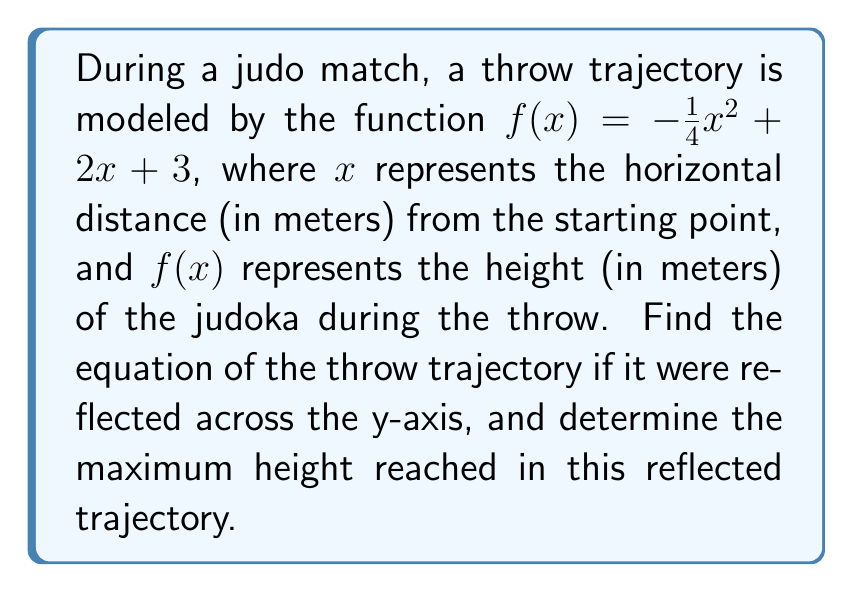Teach me how to tackle this problem. To solve this problem, we'll follow these steps:

1) To reflect a function across the y-axis, we replace every $x$ with $-x$ in the original function. This gives us:

   $g(x) = -\frac{1}{4}(-x)^2 + 2(-x) + 3$

2) Simplify the equation:
   $g(x) = -\frac{1}{4}x^2 - 2x + 3$

3) This is the equation of the reflected trajectory.

4) To find the maximum height, we need to find the vertex of this parabola. For a quadratic function in the form $ax^2 + bx + c$, the x-coordinate of the vertex is given by $-\frac{b}{2a}$.

5) In our case, $a = -\frac{1}{4}$ and $b = -2$. So:

   $x = -\frac{-2}{2(-\frac{1}{4})} = -4$

6) To find the y-coordinate (maximum height), we substitute this x-value into our function:

   $g(-4) = -\frac{1}{4}(-4)^2 - 2(-4) + 3$
          $= -4 + 8 + 3$
          $= 7$

Therefore, the maximum height reached in the reflected trajectory is 7 meters.
Answer: The equation of the reflected trajectory is $g(x) = -\frac{1}{4}x^2 - 2x + 3$, and the maximum height reached is 7 meters. 